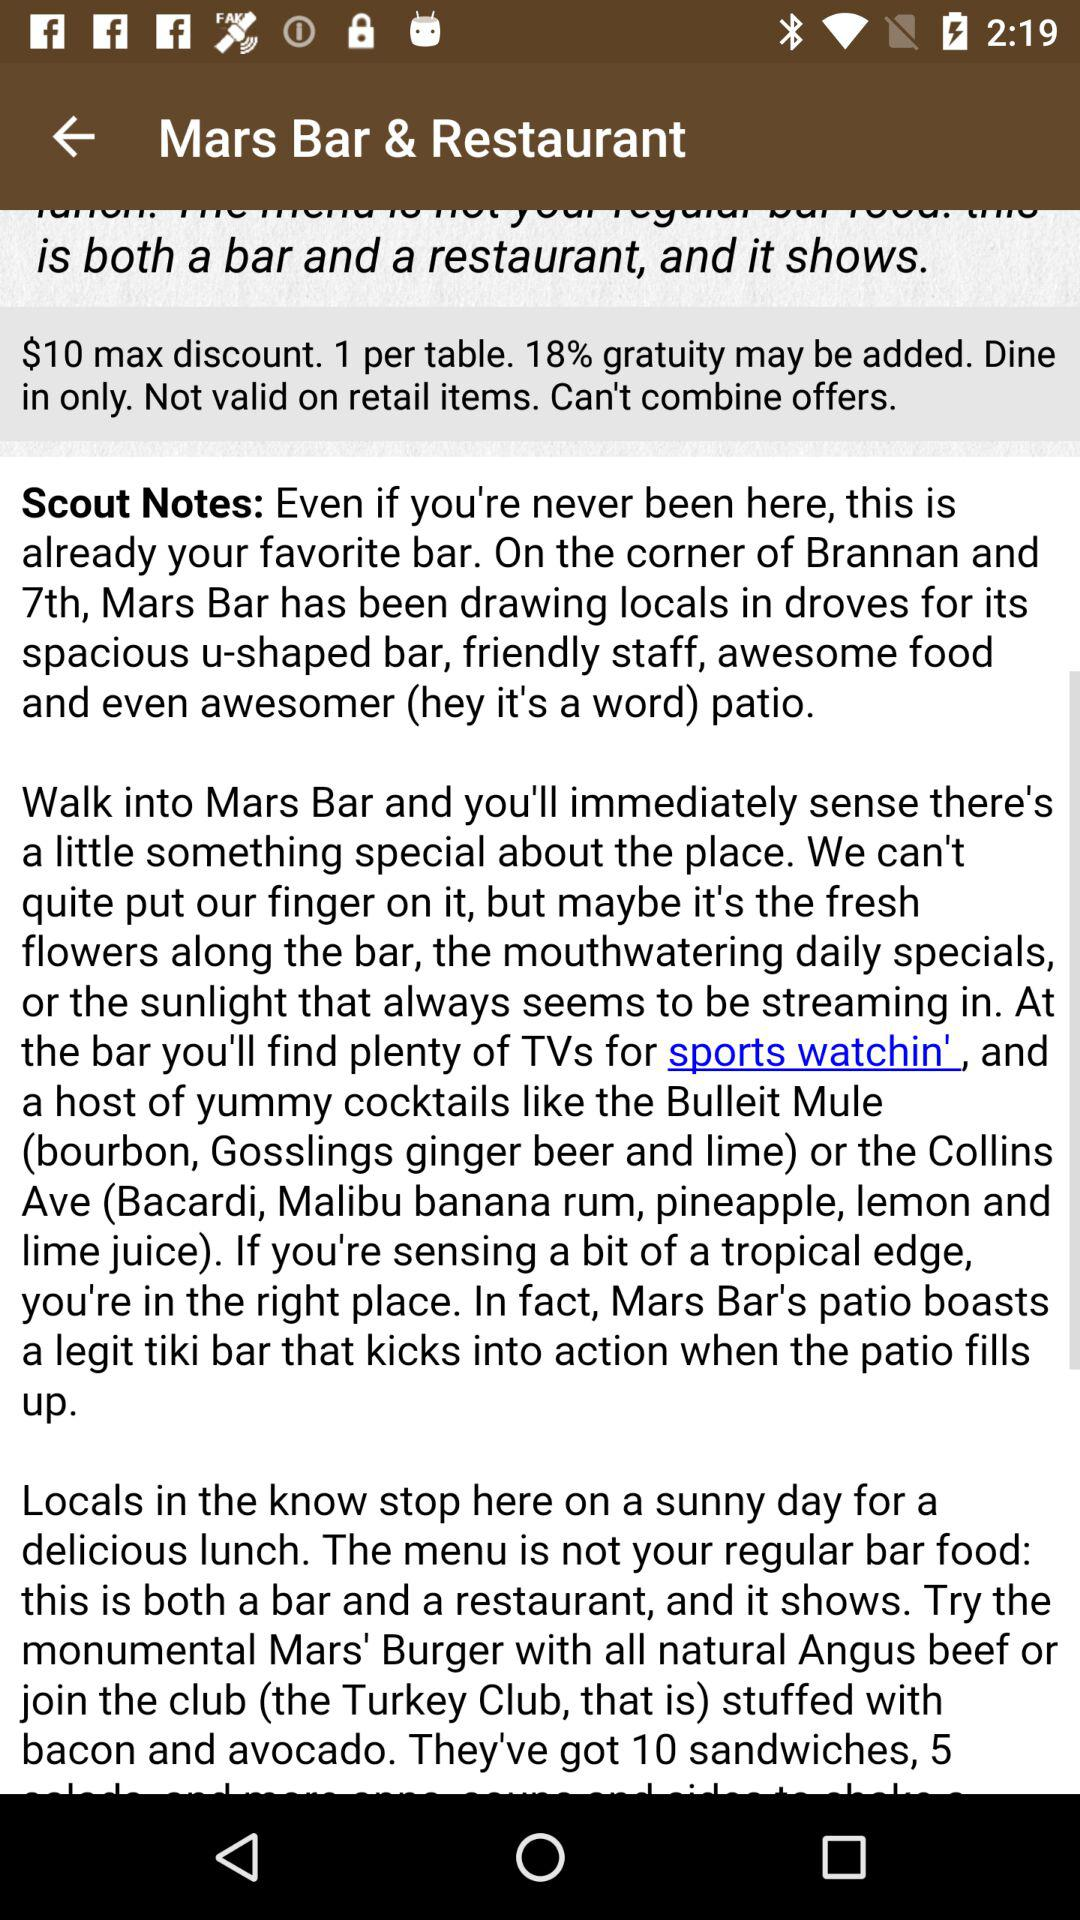What is the maximum discount? The maximum discount is $10. 